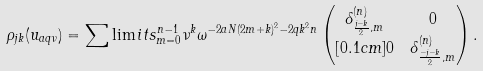<formula> <loc_0><loc_0><loc_500><loc_500>\rho _ { j k } ( u _ { a q \nu } ) & = \sum \lim i t s _ { m = 0 } ^ { n - 1 } \nu ^ { k } \omega ^ { - 2 a N ( 2 m + k ) ^ { 2 } - 2 q k ^ { 2 } n } \begin{pmatrix} \delta _ { \frac { j - k } { 2 } , m } ^ { ( n ) } & 0 \\ [ 0 . 1 c m ] 0 & \delta _ { \frac { - j - k } { 2 } , m } ^ { ( n ) } \end{pmatrix} .</formula> 